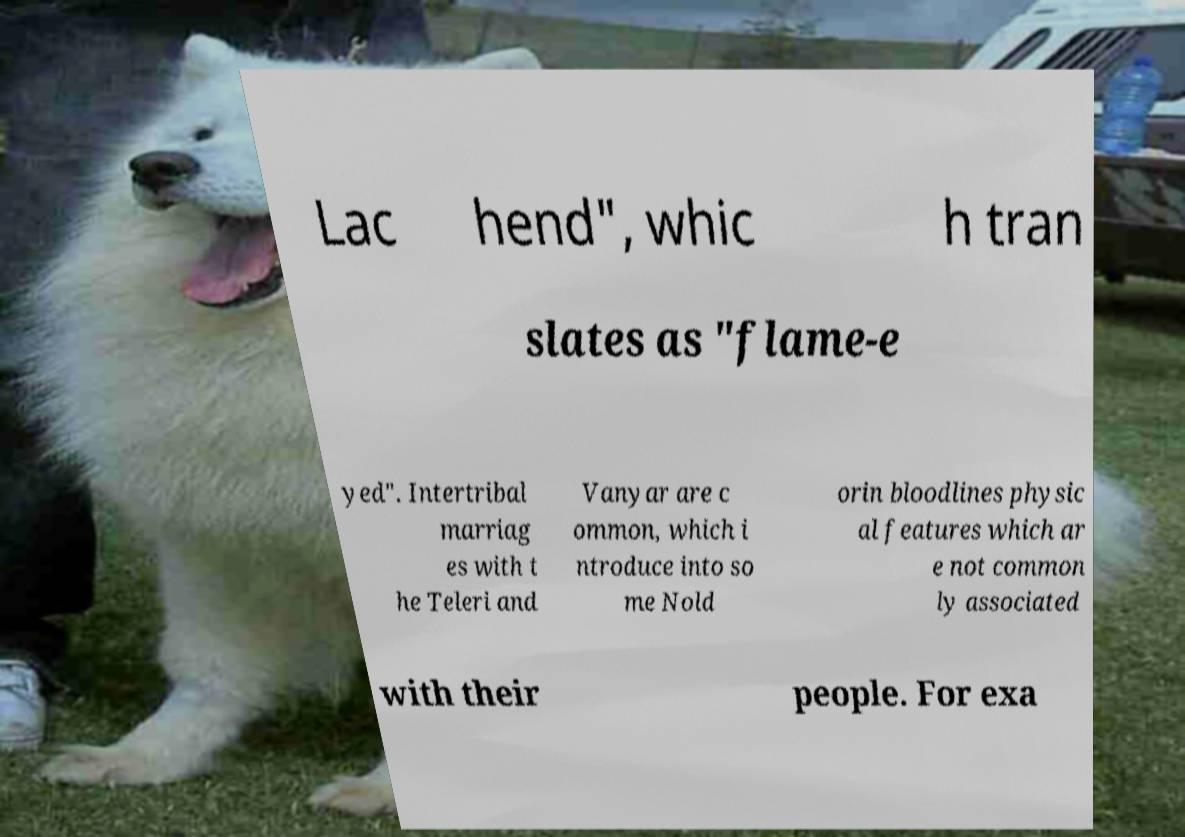Could you assist in decoding the text presented in this image and type it out clearly? Lac hend", whic h tran slates as "flame-e yed". Intertribal marriag es with t he Teleri and Vanyar are c ommon, which i ntroduce into so me Nold orin bloodlines physic al features which ar e not common ly associated with their people. For exa 